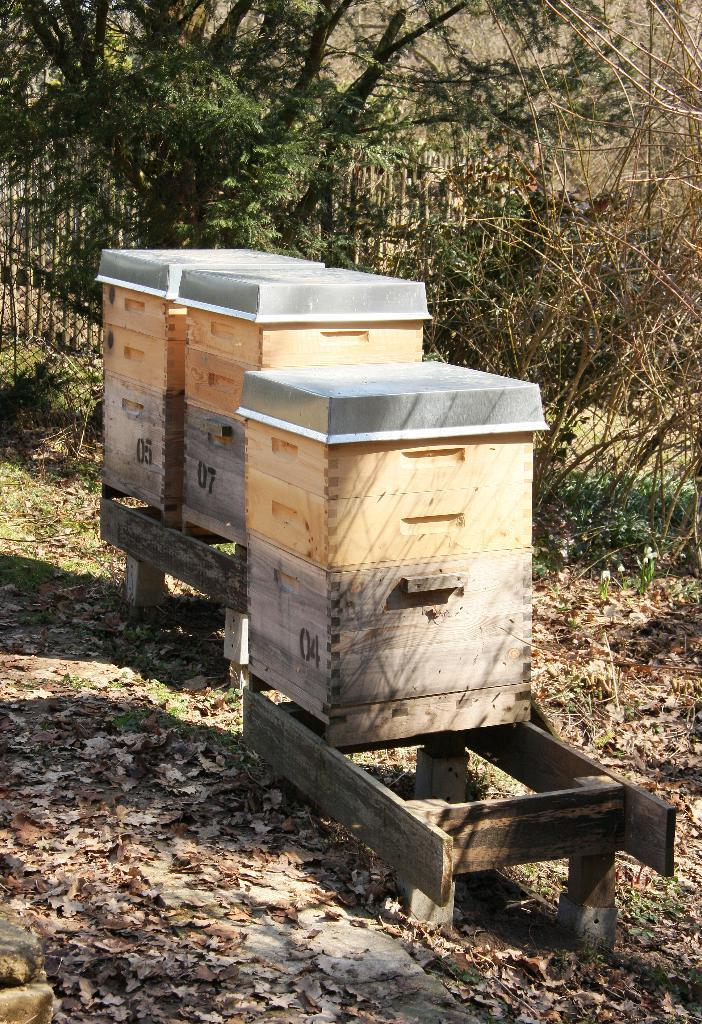What type of containers are present in the image? There are wooden containers in the image. What type of vegetation can be seen in the image? There are trees in the image. How many boys are playing in the town depicted in the image? There is no depiction of a town or boys playing in the image; it features wooden containers and trees. What type of snack is being served at the popcorn stand in the image? There is no popcorn stand present in the image. 